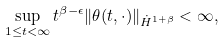Convert formula to latex. <formula><loc_0><loc_0><loc_500><loc_500>\sup _ { 1 \leq t < \infty } t ^ { \beta - \epsilon } \| \theta ( t , \cdot ) \| _ { \dot { H } ^ { 1 + \beta } } < \infty ,</formula> 